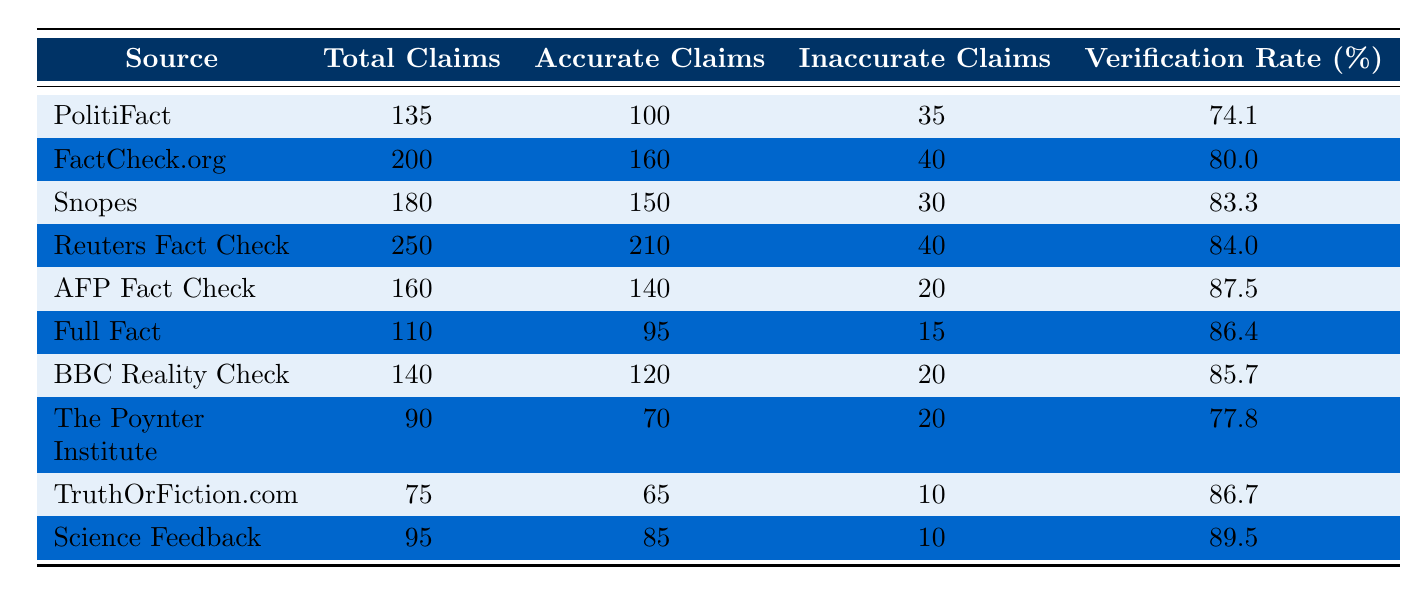What is the verification rate for AFP Fact Check? From the table, under the source "AFP Fact Check," the verification rate is listed as 87.5%.
Answer: 87.5% How many total claims were fact-checked by FactCheck.org? The table shows that FactCheck.org had a total of 200 claims fact-checked.
Answer: 200 Which source has the highest verification rate? By comparing the verification rates in the table, Science Feedback has the highest verification rate at 89.5%.
Answer: 89.5% What is the difference in the number of accurate claims between Snopes and Full Fact? Snopes has 150 accurate claims, while Full Fact has 95. The difference is 150 - 95 = 55.
Answer: 55 What percentage of claims were inaccurate for Reuters Fact Check? Reuters Fact Check has 40 inaccurate claims out of 250 total claims, which is (40/250)*100 = 16%.
Answer: 16% How many total claims were fact-checked by the combined sources of PolitiFact and BBC Reality Check? PolitiFact has 135 total claims and BBC Reality Check has 140. Adding them gives 135 + 140 = 275.
Answer: 275 Did Science Feedback have more accurate claims than AFP Fact Check? Science Feedback had 85 accurate claims while AFP Fact Check had 140, so AFP Fact Check had more accurate claims.
Answer: No What is the average verification rate of all the sources listed? To calculate the average, sum up all verification rates (74.1 + 80 + 83.3 + 84 + 87.5 + 86.4 + 85.7 + 77.8 + 86.7 + 89.5 =  839.0) and divide by the number of sources (10), which equals 839.0 / 10 = 83.9%.
Answer: 83.9% Identify the source with the lowest number of total claims? By reviewing the total claims of each source, The Poynter Institute has the lowest total claims at 90.
Answer: 90 What fraction of claims were inaccurate for TruthOrFiction.com? TruthOrFiction.com had 10 inaccurate claims out of 75 total, which makes it 10/75 = 0.1333 or 13.33%.
Answer: 13.33% 